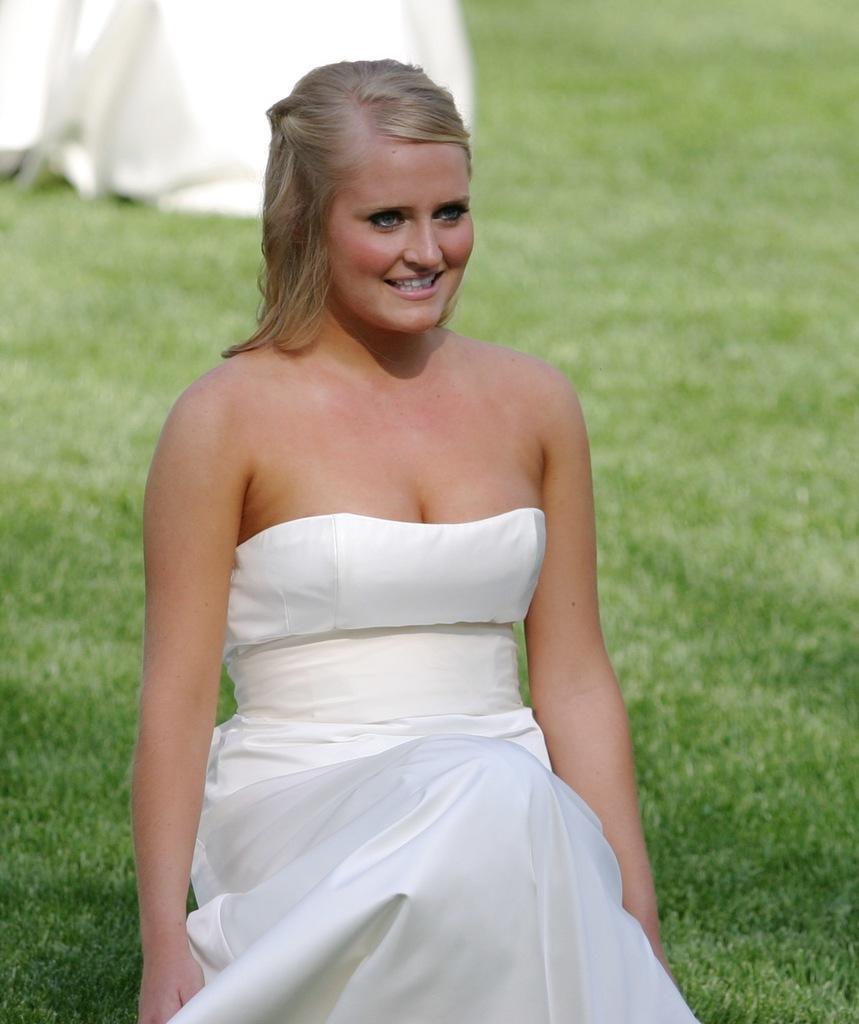Could you give a brief overview of what you see in this image? In this image we can see a woman smiling. In the background we can see the grass. 